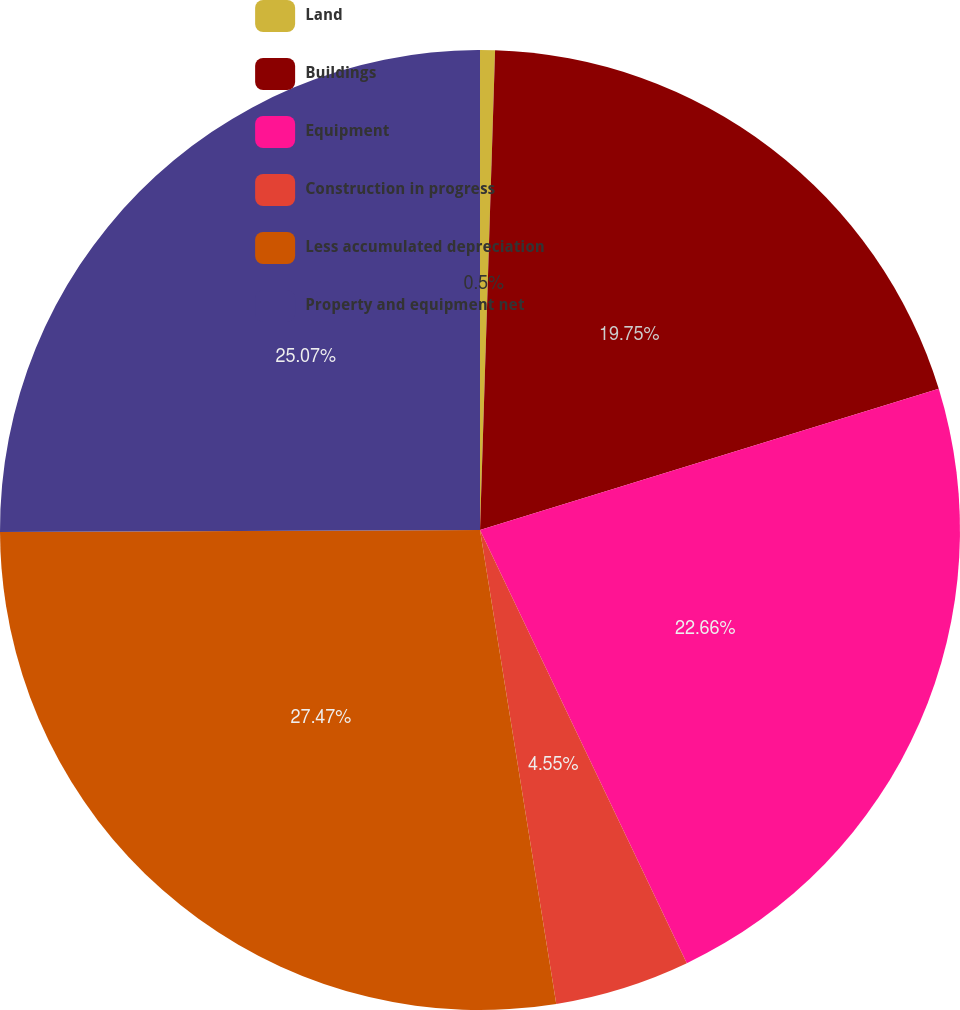<chart> <loc_0><loc_0><loc_500><loc_500><pie_chart><fcel>Land<fcel>Buildings<fcel>Equipment<fcel>Construction in progress<fcel>Less accumulated depreciation<fcel>Property and equipment net<nl><fcel>0.5%<fcel>19.75%<fcel>22.66%<fcel>4.55%<fcel>27.47%<fcel>25.07%<nl></chart> 